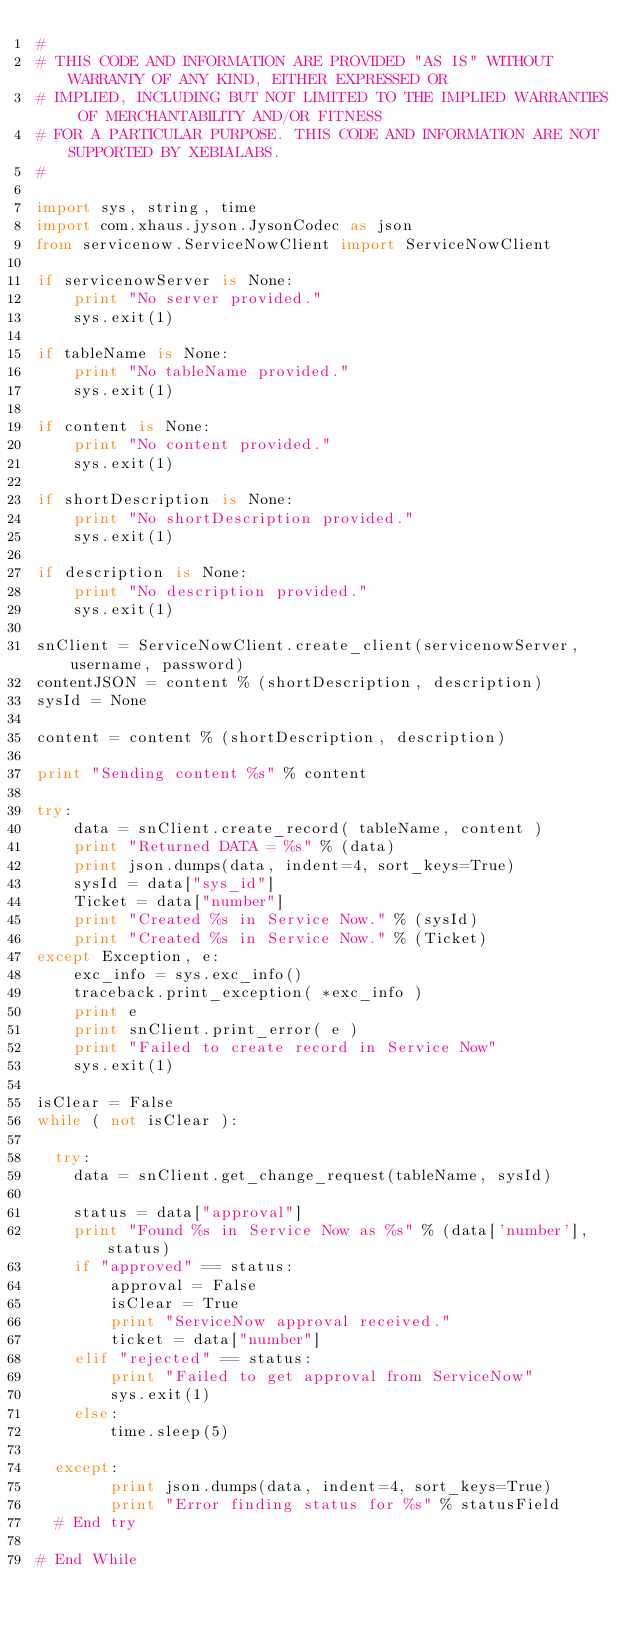Convert code to text. <code><loc_0><loc_0><loc_500><loc_500><_Python_>#
# THIS CODE AND INFORMATION ARE PROVIDED "AS IS" WITHOUT WARRANTY OF ANY KIND, EITHER EXPRESSED OR
# IMPLIED, INCLUDING BUT NOT LIMITED TO THE IMPLIED WARRANTIES OF MERCHANTABILITY AND/OR FITNESS
# FOR A PARTICULAR PURPOSE. THIS CODE AND INFORMATION ARE NOT SUPPORTED BY XEBIALABS.
#

import sys, string, time
import com.xhaus.jyson.JysonCodec as json
from servicenow.ServiceNowClient import ServiceNowClient

if servicenowServer is None:
    print "No server provided."
    sys.exit(1)

if tableName is None:
    print "No tableName provided."
    sys.exit(1)

if content is None:
    print "No content provided."
    sys.exit(1)

if shortDescription is None:
    print "No shortDescription provided."
    sys.exit(1)

if description is None:
    print "No description provided."
    sys.exit(1)

snClient = ServiceNowClient.create_client(servicenowServer, username, password)
contentJSON = content % (shortDescription, description)
sysId = None

content = content % (shortDescription, description)

print "Sending content %s" % content

try:
    data = snClient.create_record( tableName, content )
    print "Returned DATA = %s" % (data)
    print json.dumps(data, indent=4, sort_keys=True)
    sysId = data["sys_id"]
    Ticket = data["number"]
    print "Created %s in Service Now." % (sysId)
    print "Created %s in Service Now." % (Ticket)
except Exception, e:
    exc_info = sys.exc_info()
    traceback.print_exception( *exc_info )
    print e
    print snClient.print_error( e )
    print "Failed to create record in Service Now"
    sys.exit(1)

isClear = False
while ( not isClear ):

  try:
    data = snClient.get_change_request(tableName, sysId)

    status = data["approval"]
    print "Found %s in Service Now as %s" % (data['number'], status)
    if "approved" == status:
        approval = False
        isClear = True
        print "ServiceNow approval received."
        ticket = data["number"]
    elif "rejected" == status:
        print "Failed to get approval from ServiceNow"
        sys.exit(1)
    else:
        time.sleep(5) 

  except:
        print json.dumps(data, indent=4, sort_keys=True)
        print "Error finding status for %s" % statusField
  # End try

# End While
</code> 